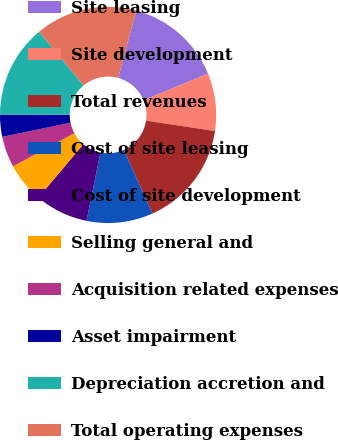Convert chart. <chart><loc_0><loc_0><loc_500><loc_500><pie_chart><fcel>Site leasing<fcel>Site development<fcel>Total revenues<fcel>Cost of site leasing<fcel>Cost of site development<fcel>Selling general and<fcel>Acquisition related expenses<fcel>Asset impairment<fcel>Depreciation accretion and<fcel>Total operating expenses<nl><fcel>14.57%<fcel>8.61%<fcel>15.89%<fcel>9.93%<fcel>7.95%<fcel>5.96%<fcel>4.64%<fcel>3.31%<fcel>13.91%<fcel>15.23%<nl></chart> 